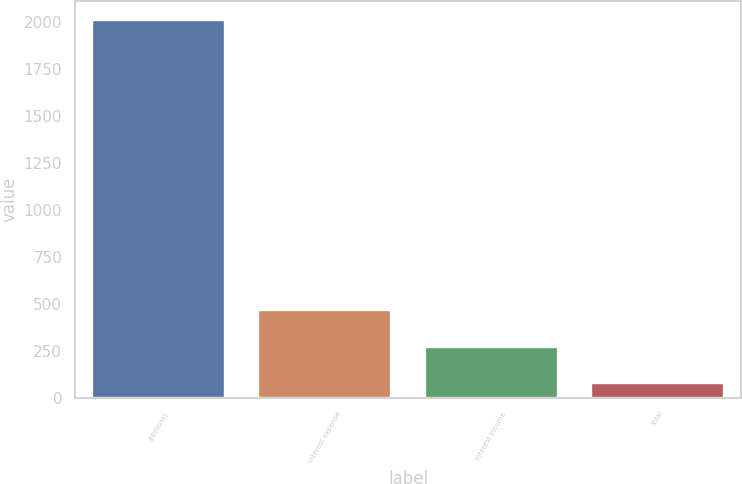Convert chart. <chart><loc_0><loc_0><loc_500><loc_500><bar_chart><fcel>(Millions)<fcel>Interest expense<fcel>Interest income<fcel>Total<nl><fcel>2007<fcel>463.8<fcel>270.9<fcel>78<nl></chart> 